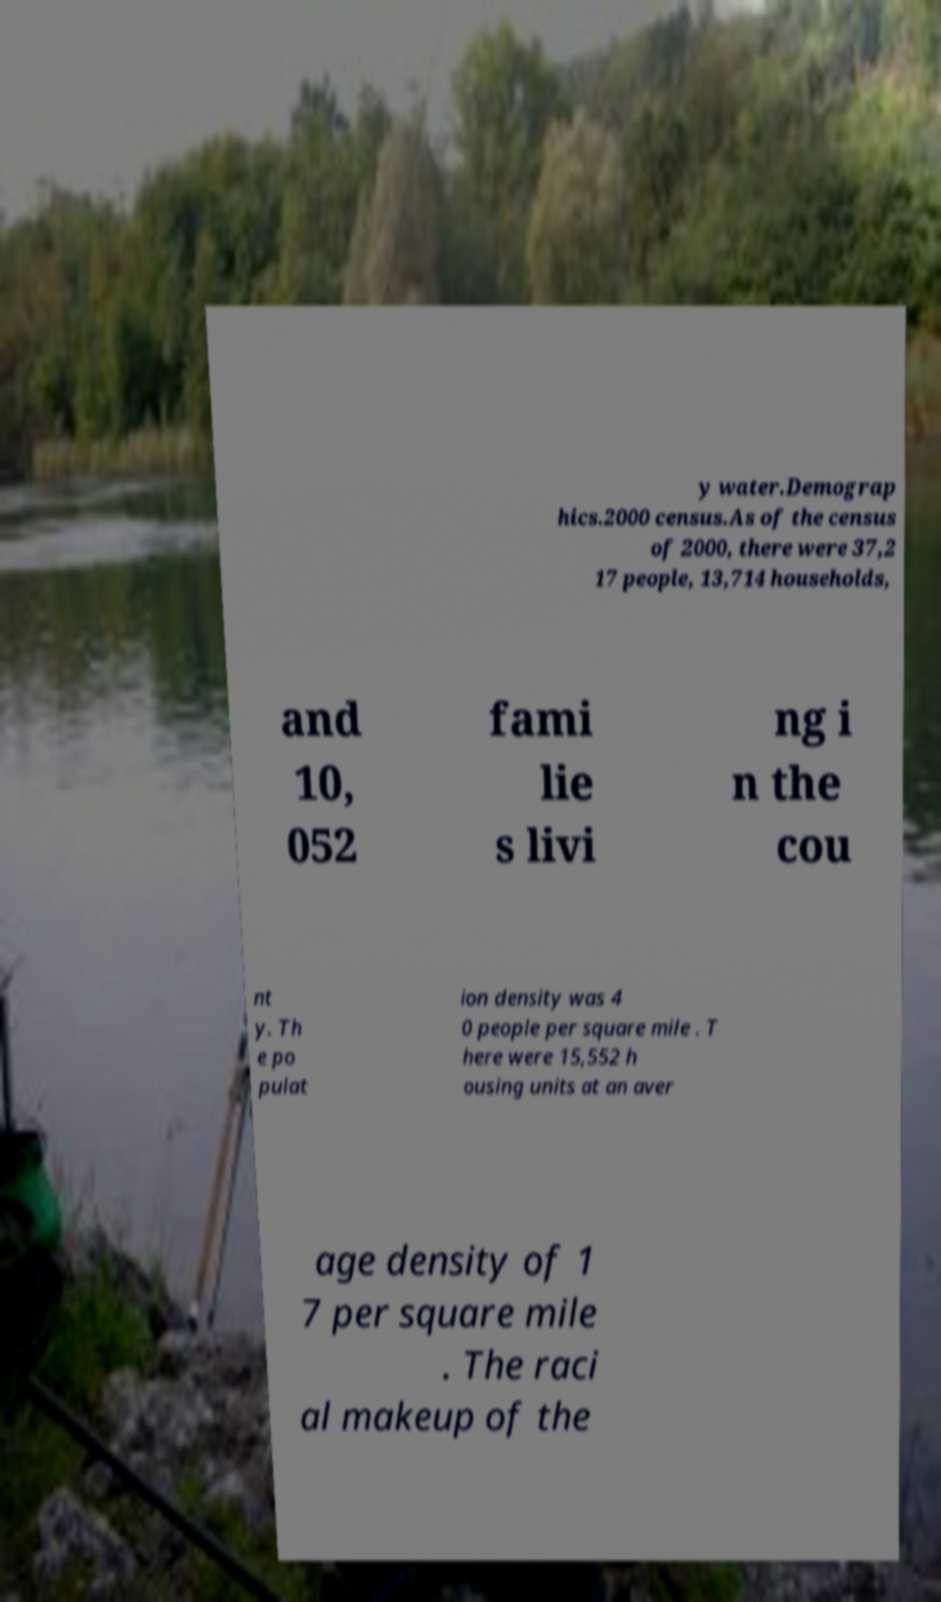For documentation purposes, I need the text within this image transcribed. Could you provide that? y water.Demograp hics.2000 census.As of the census of 2000, there were 37,2 17 people, 13,714 households, and 10, 052 fami lie s livi ng i n the cou nt y. Th e po pulat ion density was 4 0 people per square mile . T here were 15,552 h ousing units at an aver age density of 1 7 per square mile . The raci al makeup of the 